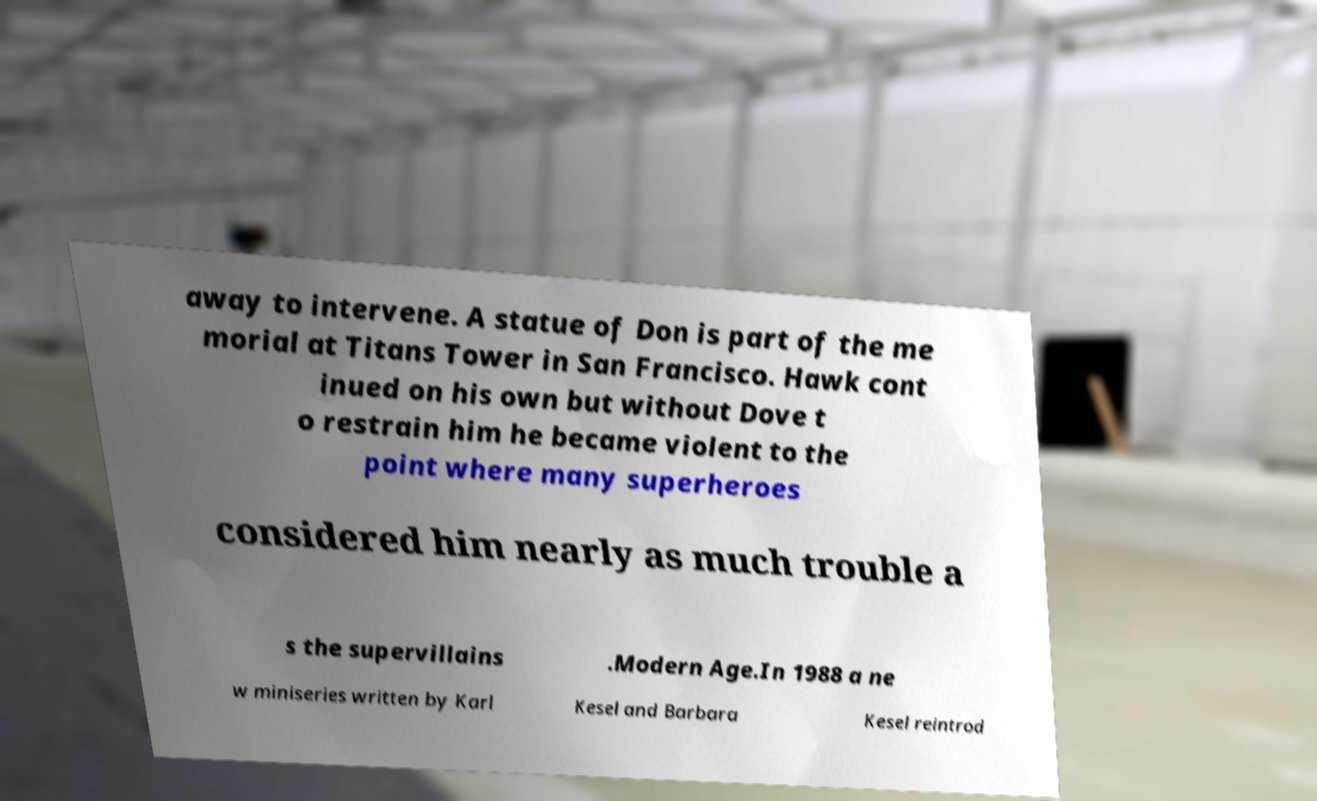What messages or text are displayed in this image? I need them in a readable, typed format. away to intervene. A statue of Don is part of the me morial at Titans Tower in San Francisco. Hawk cont inued on his own but without Dove t o restrain him he became violent to the point where many superheroes considered him nearly as much trouble a s the supervillains .Modern Age.In 1988 a ne w miniseries written by Karl Kesel and Barbara Kesel reintrod 